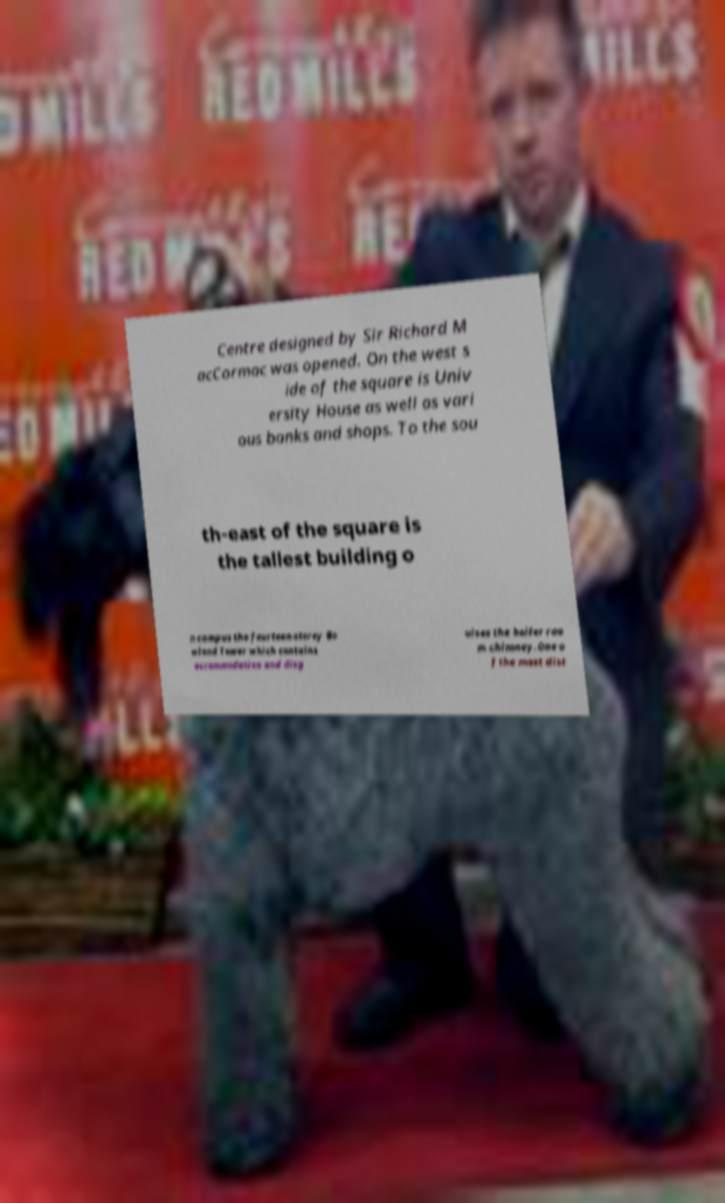Can you accurately transcribe the text from the provided image for me? Centre designed by Sir Richard M acCormac was opened. On the west s ide of the square is Univ ersity House as well as vari ous banks and shops. To the sou th-east of the square is the tallest building o n campus the fourteen-storey Bo wland Tower which contains accommodation and disg uises the boiler roo m chimney.One o f the most dist 